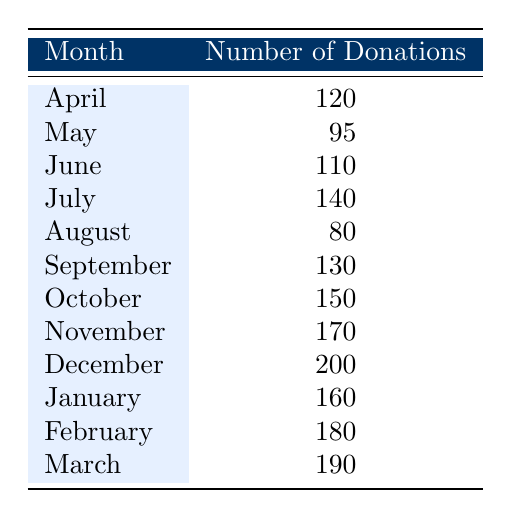What was the month with the highest number of donations? By examining the table, I see that December has the highest number of donations, with 200 donations recorded.
Answer: December What is the number of donations received in June? The table shows that June received 110 donations.
Answer: 110 Which month had fewer donations: April or August? According to the table, April had 120 donations and August had 80 donations; therefore, August had fewer donations.
Answer: August What is the total number of donations received in the first half of the fiscal year (April to September)? To find this, I add the donations from April (120), May (95), June (110), July (140), August (80), and September (130). The total is 120 + 95 + 110 + 140 + 80 + 130 = 775 donations.
Answer: 775 True or False: January had more donations than November. The table indicates January had 160 donations and November had 170 donations, making this statement false.
Answer: False What was the average number of donations received from October to March? First, I add the donations from October (150), November (170), December (200), January (160), February (180), and March (190) to get a total of 1,050 donations. Since there are 6 months, I then divide 1,050 by 6, resulting in an average of 175 donations.
Answer: 175 How many months had more than 150 donations? By reviewing the table, I see that October (150), November (170), December (200), January (160), February (180), and March (190) had more than 150 donations. This totals to 5 months, as August (80) and May (95) are below that number.
Answer: 5 Which two consecutive months had the lowest combined donations? Looking at the number of donations, August had 80 and September had 130, resulting in a combined total of 210. In contrast, May (95) and June (110) total 205. The two consecutive months with the lowest donations were May and June.
Answer: May and June How many donations did we receive in the last quarter of the fiscal year (January to March)? I add the donations for the last quarter: January (160), February (180), and March (190). The total equals 160 + 180 + 190 = 530 donations in that quarter.
Answer: 530 